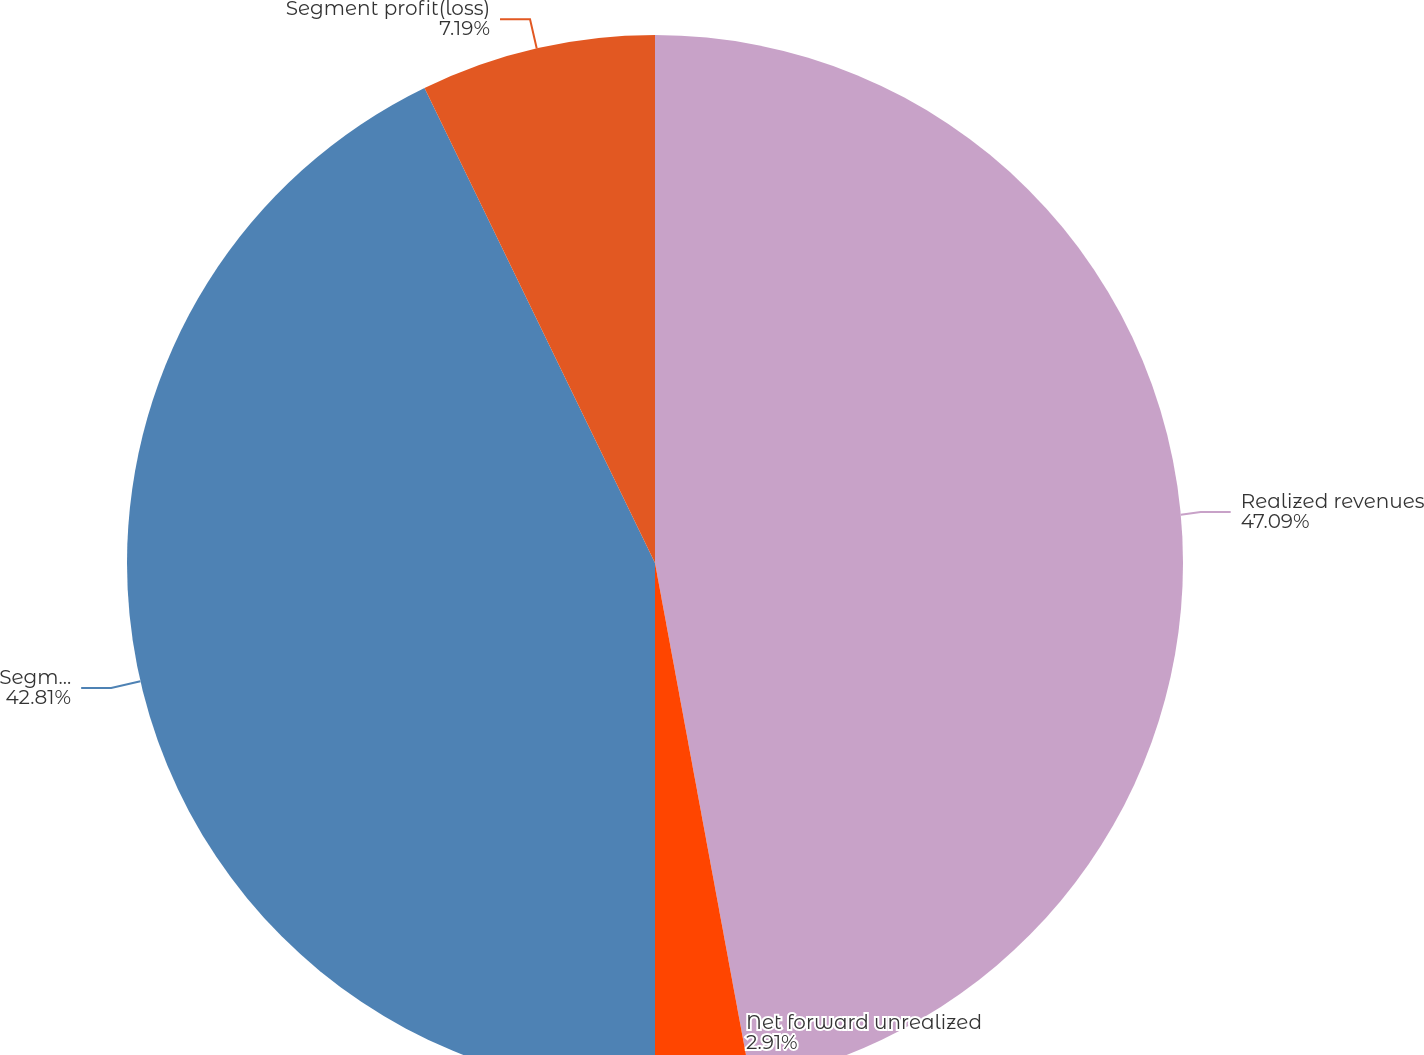Convert chart to OTSL. <chart><loc_0><loc_0><loc_500><loc_500><pie_chart><fcel>Realized revenues<fcel>Net forward unrealized<fcel>Segment revenues<fcel>Segment profit(loss)<nl><fcel>47.09%<fcel>2.91%<fcel>42.81%<fcel>7.19%<nl></chart> 